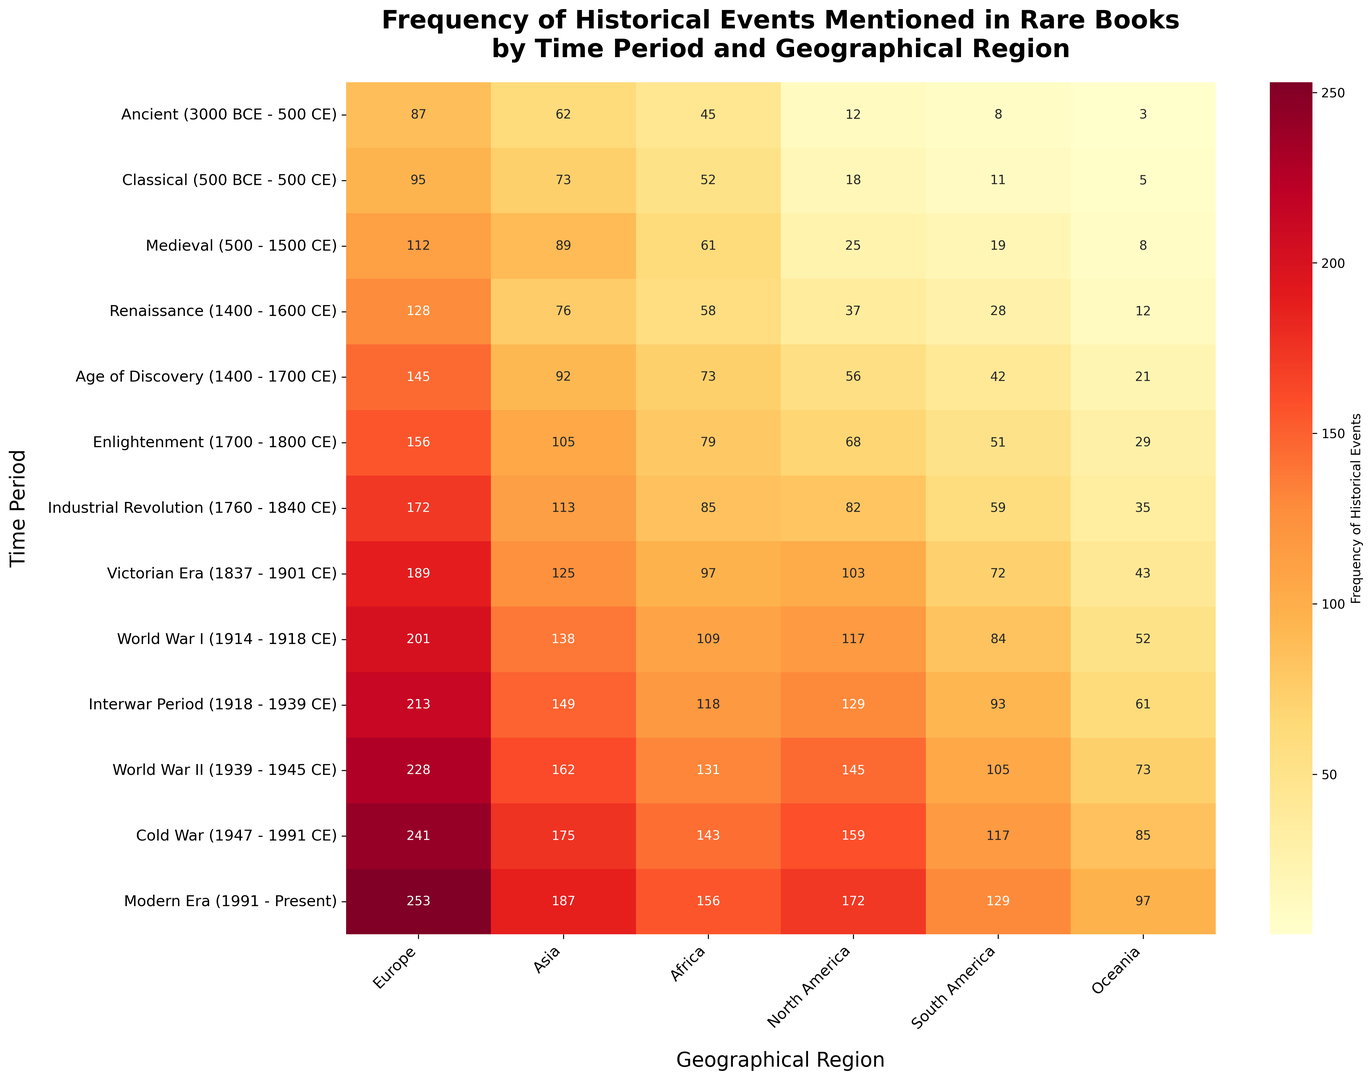Which geographical region saw the highest frequency of historical events in the World War II period? To find the answer, look at the intersection of the World War II row and each geographical region column. The highest value in this row is 228 for Europe.
Answer: Europe What is the frequency difference between Europe and Asia during the Classical period? Refer to the Classical period row and subtract the value of Asia (73) from the value of Europe (95). The calculation is 95 - 73.
Answer: 22 Between the Medieval and Modern Era, which time period has a higher frequency of events mentioned in North America? Compare the values for North America in the Medieval period (25) and Modern Era (172). The Modern Era has a higher value.
Answer: Modern Era Which time period shows the highest frequency in South America and what is the frequency? Check the values in the South America column. The highest value is 129, which corresponds to the Modern Era.
Answer: Modern Era with 129 What is the sum of frequencies for Oceania across all time periods? Sum the values in the Oceania column: 3 + 5 + 8 + 12 + 21 + 29 + 35 + 43 + 52 + 61 + 73 + 85 + 97 equals 524.
Answer: 524 How does the frequency of historical events in Africa during the Enlightenment period compare to that in the Interwar Period? Check the values for Africa in both periods: Enlightenment (79) and Interwar Period (118). The Interwar Period has a higher frequency.
Answer: Interwar Period What time period and region have the least frequency of historical events mentioned? Scan the entire heatmap to identify the smallest value. The smallest value is 3 in Oceania during the Ancient period.
Answer: Ancient period in Oceania How much did the frequency of events in South America increase from the Renaissance to the Age of Discovery? Subtract the frequency of South America during Renaissance (28) from the frequency during the Age of Discovery (42). The calculation is 42 - 28.
Answer: 14 What is the average frequency of historical events mentioned in North America from the Age of Discovery to the Enlightenment period inclusive? Sum the frequencies of North America from the Age of Discovery (56), Enlightenment (68), and Industrial Revolution (82), then divide by 3. The calculation is (56 + 68 + 82) / 3.
Answer: 68.67 In the Cold War period, which region had the second lowest frequency of historical events mentioned? First identify frequencies for all regions during the Cold War: Europe (241), Asia (175), Africa (143), North America (159), South America (117), and Oceania (85). The second lowest frequency is 117 for South America.
Answer: South America 